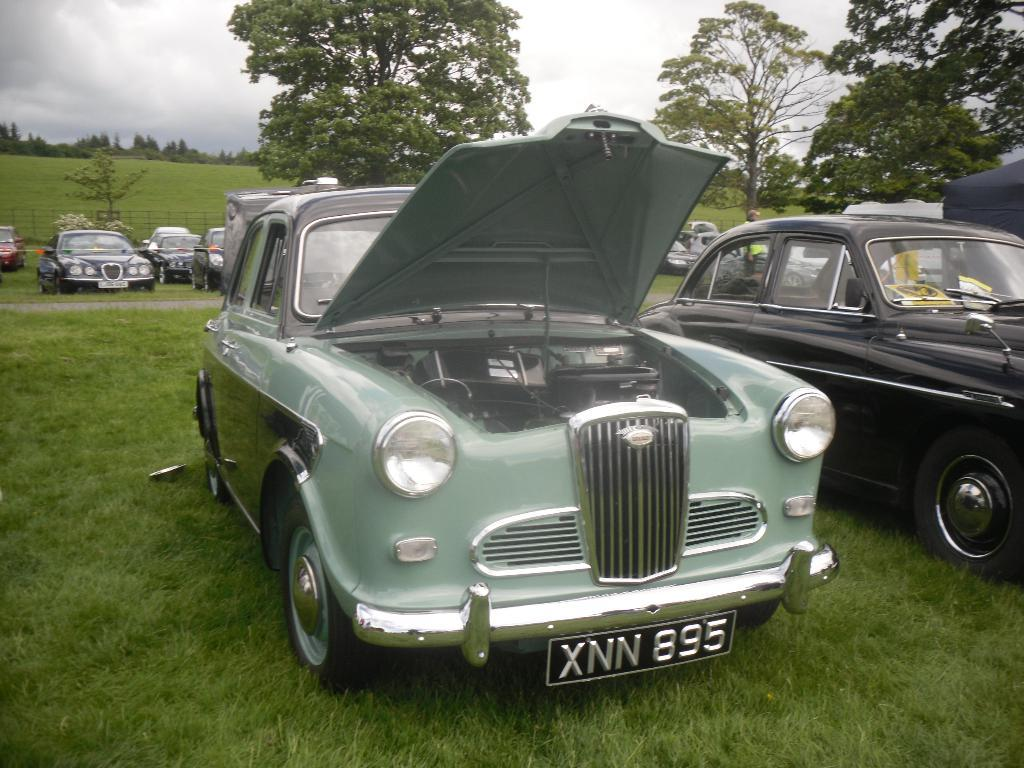What is the main subject in the foreground of the image? There are fleets of vehicles in the foreground of the image. What is the surface on which the vehicles are placed? The vehicles are on grass. What can be seen in the background of the image? There is a fence, trees, and the sky visible in the background of the image. Can you describe the setting of the image? The image might have been taken in a park, given the presence of grass, trees, and a fence. What type of peace symbol can be seen on the vehicles in the image? There is no peace symbol visible on the vehicles in the image. Can you describe the monkey playing with the tramp in the image? There is no monkey or tramp present in the image; it features fleets of vehicles on grass. 